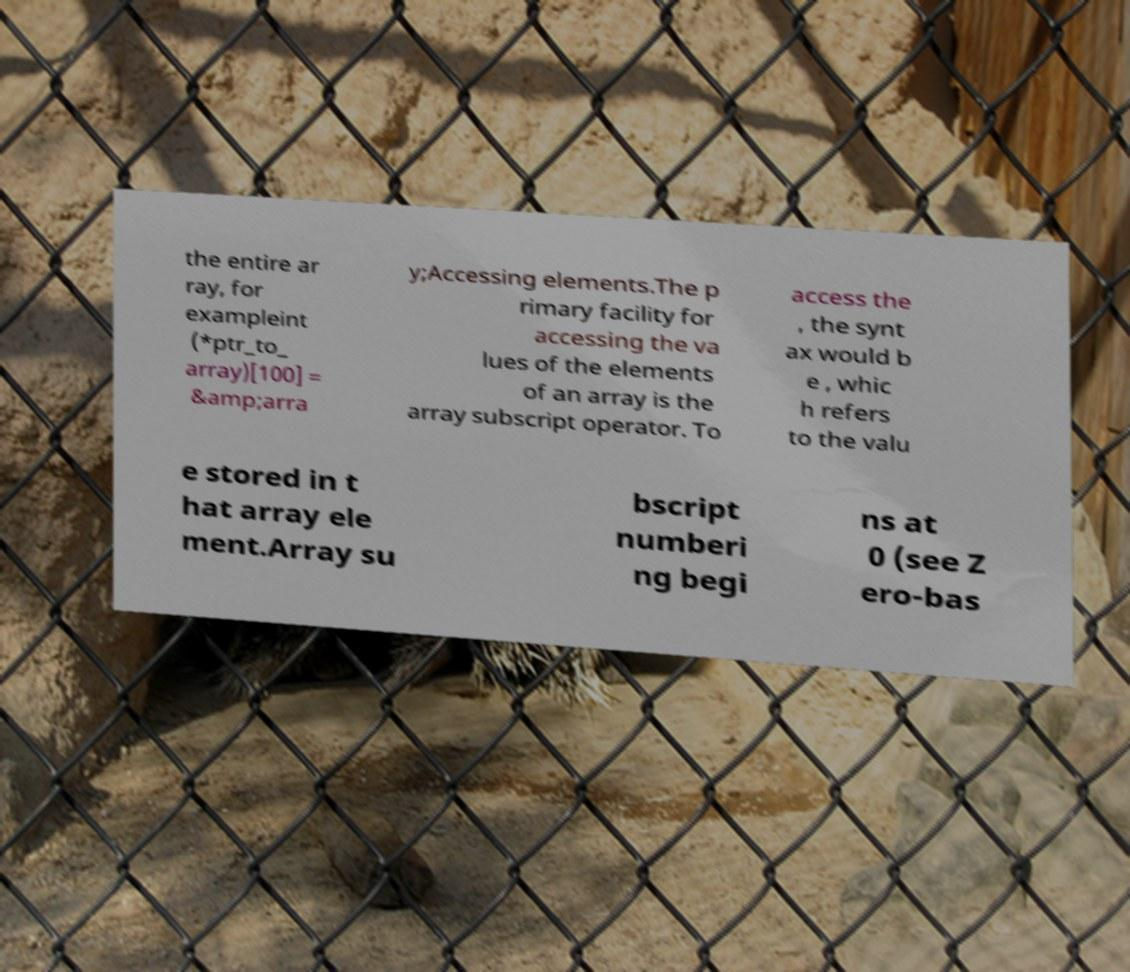Could you extract and type out the text from this image? the entire ar ray, for exampleint (*ptr_to_ array)[100] = &amp;arra y;Accessing elements.The p rimary facility for accessing the va lues of the elements of an array is the array subscript operator. To access the , the synt ax would b e , whic h refers to the valu e stored in t hat array ele ment.Array su bscript numberi ng begi ns at 0 (see Z ero-bas 